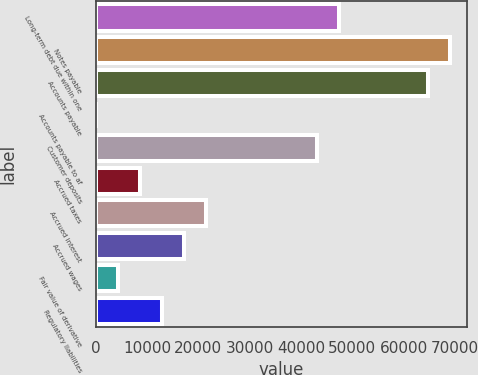Convert chart. <chart><loc_0><loc_0><loc_500><loc_500><bar_chart><fcel>Long-term debt due within one<fcel>Notes payable<fcel>Accounts payable<fcel>Accounts payable to af<fcel>Customer deposits<fcel>Accrued taxes<fcel>Accrued interest<fcel>Accrued wages<fcel>Fair value of derivative<fcel>Regulatory liabilities<nl><fcel>47417.1<fcel>68962.6<fcel>64653.5<fcel>17<fcel>43108<fcel>8635.2<fcel>21562.5<fcel>17253.4<fcel>4326.1<fcel>12944.3<nl></chart> 